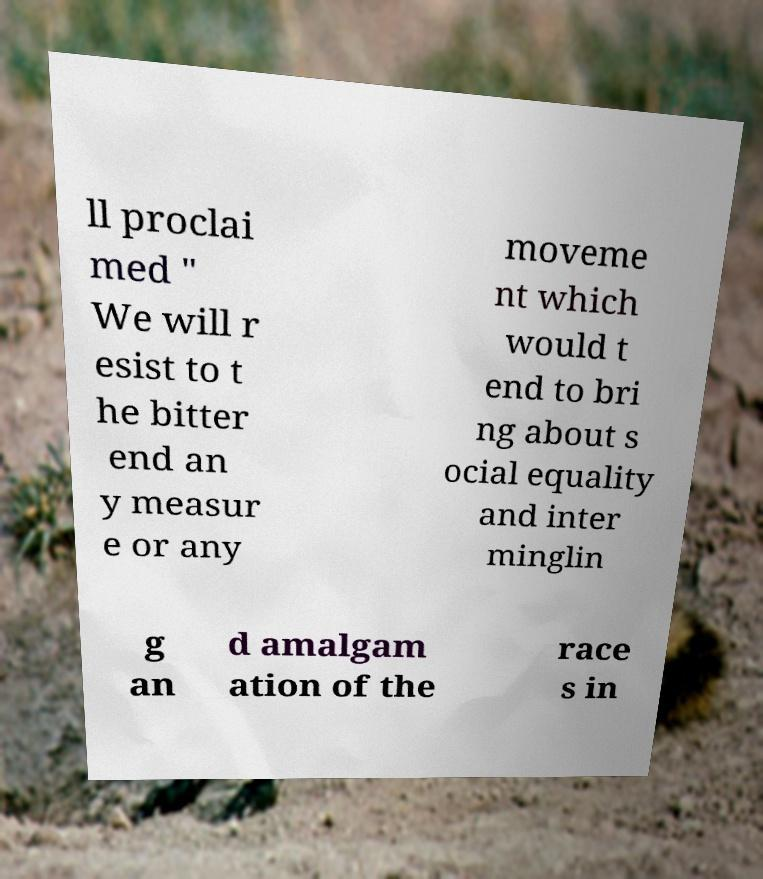Can you read and provide the text displayed in the image?This photo seems to have some interesting text. Can you extract and type it out for me? ll proclai med " We will r esist to t he bitter end an y measur e or any moveme nt which would t end to bri ng about s ocial equality and inter minglin g an d amalgam ation of the race s in 